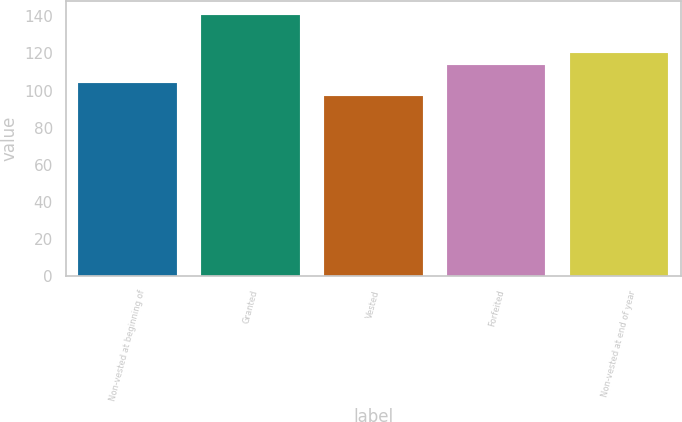Convert chart. <chart><loc_0><loc_0><loc_500><loc_500><bar_chart><fcel>Non-vested at beginning of<fcel>Granted<fcel>Vested<fcel>Forfeited<fcel>Non-vested at end of year<nl><fcel>104<fcel>141<fcel>97<fcel>114<fcel>120<nl></chart> 